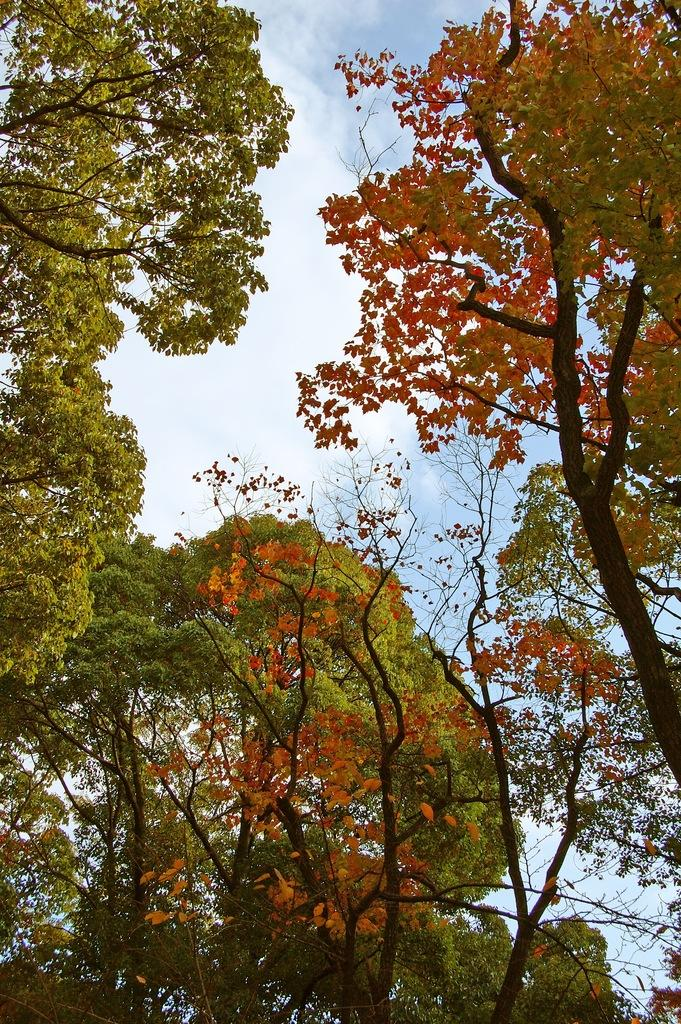What type of vegetation can be seen in the image? There are trees in the image. What part of the natural environment is visible in the image? The sky is visible in the image. What can be observed in the sky? Clouds are present in the sky. What type of mask is hanging from the tree in the image? There is no mask present in the image; it only features trees and the sky. 